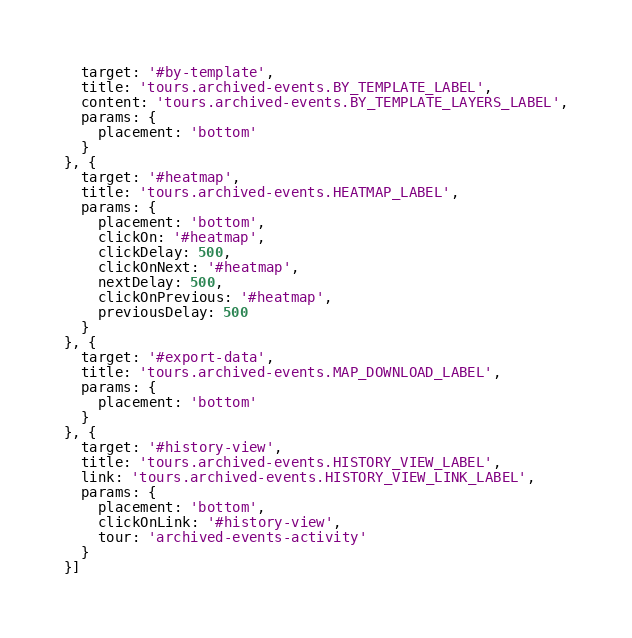Convert code to text. <code><loc_0><loc_0><loc_500><loc_500><_JavaScript_>  target: '#by-template',
  title: 'tours.archived-events.BY_TEMPLATE_LABEL',
  content: 'tours.archived-events.BY_TEMPLATE_LAYERS_LABEL',
  params: {
    placement: 'bottom'
  }
}, {
  target: '#heatmap',
  title: 'tours.archived-events.HEATMAP_LABEL',
  params: {
    placement: 'bottom',
    clickOn: '#heatmap',
    clickDelay: 500,
    clickOnNext: '#heatmap',
    nextDelay: 500,
    clickOnPrevious: '#heatmap',
    previousDelay: 500
  }
}, {
  target: '#export-data',
  title: 'tours.archived-events.MAP_DOWNLOAD_LABEL',
  params: {
    placement: 'bottom'
  }
}, {
  target: '#history-view',
  title: 'tours.archived-events.HISTORY_VIEW_LABEL',
  link: 'tours.archived-events.HISTORY_VIEW_LINK_LABEL',
  params: {
    placement: 'bottom',
    clickOnLink: '#history-view',
    tour: 'archived-events-activity'
  }
}]
</code> 